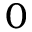Convert formula to latex. <formula><loc_0><loc_0><loc_500><loc_500>0</formula> 